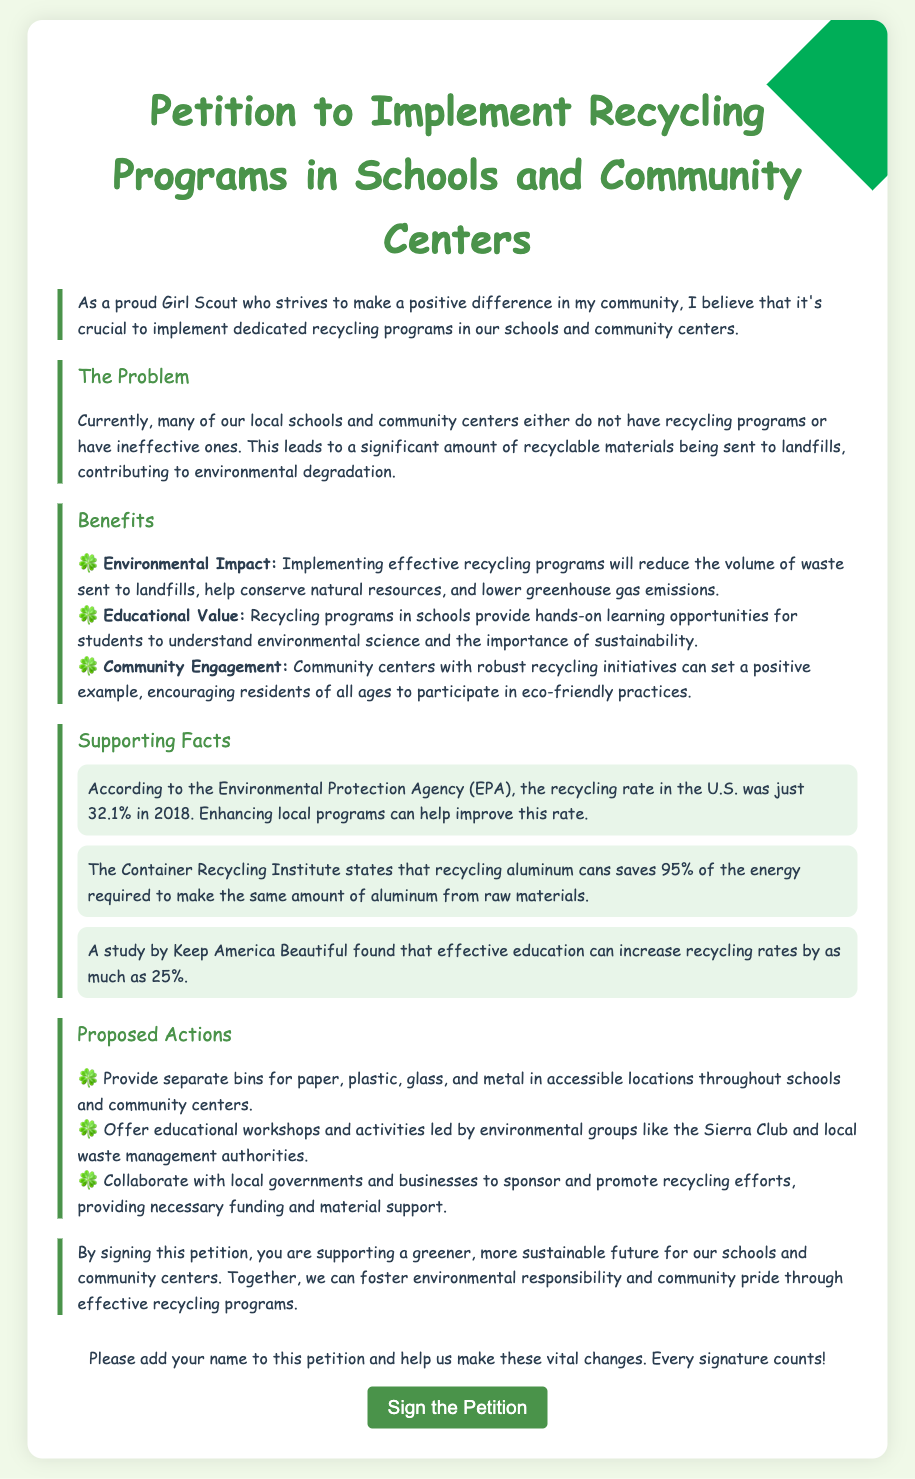What is the title of the petition? The title of the petition is the heading at the top of the document, which introduces its purpose.
Answer: Petition to Implement Recycling Programs in Schools and Community Centers What is one problem mentioned in the petition? The petition addresses the lack of effective recycling programs in local schools and community centers as a significant problem.
Answer: Ineffective recycling programs What is one proposed action from the document? The document lists several actions that are proposed to improve recycling programs, focusing on practical measures.
Answer: Provide separate bins for paper, plastic, glass, and metal What organization is suggested for collaboration in the petition? The petition points out the Sierra Club as one of the environmental groups to collaborate with for educational efforts.
Answer: Sierra Club What percentage of the U.S. recycling rate was recorded in 2018? The document cites a specific statistic from the Environmental Protection Agency regarding the recycling rate in a particular year.
Answer: 32.1% How much energy is saved from recycling aluminum cans? The document states a specific percentage of energy saved by recycling as compared to producing aluminum from raw materials.
Answer: 95% What is one benefit of recycling programs mentioned? The document highlights various benefits of implementing recycling programs; one can be selected to describe the impact on education or the environment.
Answer: Educational Value How many actions are proposed in the petition? The document lists specific actions intended to enhance recycling programs, and the total number of proposed actions can be counted.
Answer: Three What type of document is this? The structure and purpose of the document categorize it within a specific format aimed at advocating for change.
Answer: Petition 